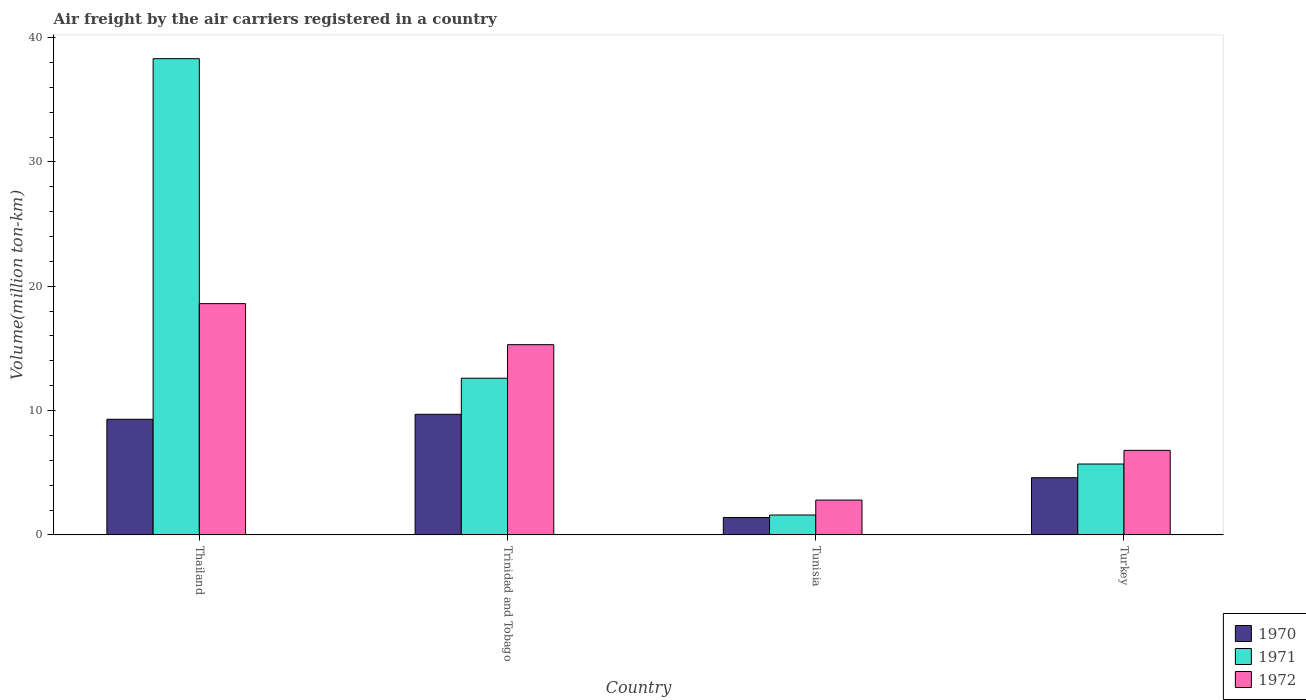Are the number of bars per tick equal to the number of legend labels?
Offer a terse response. Yes. How many bars are there on the 2nd tick from the left?
Your answer should be very brief. 3. How many bars are there on the 1st tick from the right?
Provide a short and direct response. 3. In how many cases, is the number of bars for a given country not equal to the number of legend labels?
Your answer should be very brief. 0. What is the volume of the air carriers in 1970 in Trinidad and Tobago?
Ensure brevity in your answer.  9.7. Across all countries, what is the maximum volume of the air carriers in 1970?
Make the answer very short. 9.7. Across all countries, what is the minimum volume of the air carriers in 1971?
Provide a succinct answer. 1.6. In which country was the volume of the air carriers in 1971 maximum?
Your answer should be very brief. Thailand. In which country was the volume of the air carriers in 1972 minimum?
Give a very brief answer. Tunisia. What is the total volume of the air carriers in 1971 in the graph?
Provide a short and direct response. 58.2. What is the difference between the volume of the air carriers in 1971 in Thailand and that in Trinidad and Tobago?
Your answer should be very brief. 25.7. What is the difference between the volume of the air carriers in 1972 in Tunisia and the volume of the air carriers in 1970 in Trinidad and Tobago?
Give a very brief answer. -6.9. What is the average volume of the air carriers in 1972 per country?
Offer a very short reply. 10.88. What is the difference between the volume of the air carriers of/in 1971 and volume of the air carriers of/in 1972 in Tunisia?
Keep it short and to the point. -1.2. What is the ratio of the volume of the air carriers in 1971 in Tunisia to that in Turkey?
Offer a very short reply. 0.28. Is the difference between the volume of the air carriers in 1971 in Trinidad and Tobago and Turkey greater than the difference between the volume of the air carriers in 1972 in Trinidad and Tobago and Turkey?
Your response must be concise. No. What is the difference between the highest and the second highest volume of the air carriers in 1971?
Keep it short and to the point. 6.9. What is the difference between the highest and the lowest volume of the air carriers in 1972?
Give a very brief answer. 15.8. In how many countries, is the volume of the air carriers in 1972 greater than the average volume of the air carriers in 1972 taken over all countries?
Ensure brevity in your answer.  2. Are all the bars in the graph horizontal?
Ensure brevity in your answer.  No. What is the difference between two consecutive major ticks on the Y-axis?
Offer a terse response. 10. Does the graph contain any zero values?
Your response must be concise. No. Does the graph contain grids?
Ensure brevity in your answer.  No. Where does the legend appear in the graph?
Your answer should be compact. Bottom right. How many legend labels are there?
Provide a succinct answer. 3. How are the legend labels stacked?
Provide a succinct answer. Vertical. What is the title of the graph?
Offer a very short reply. Air freight by the air carriers registered in a country. Does "1965" appear as one of the legend labels in the graph?
Your response must be concise. No. What is the label or title of the Y-axis?
Ensure brevity in your answer.  Volume(million ton-km). What is the Volume(million ton-km) in 1970 in Thailand?
Give a very brief answer. 9.3. What is the Volume(million ton-km) in 1971 in Thailand?
Offer a very short reply. 38.3. What is the Volume(million ton-km) in 1972 in Thailand?
Keep it short and to the point. 18.6. What is the Volume(million ton-km) of 1970 in Trinidad and Tobago?
Provide a short and direct response. 9.7. What is the Volume(million ton-km) in 1971 in Trinidad and Tobago?
Ensure brevity in your answer.  12.6. What is the Volume(million ton-km) in 1972 in Trinidad and Tobago?
Offer a very short reply. 15.3. What is the Volume(million ton-km) of 1970 in Tunisia?
Your answer should be compact. 1.4. What is the Volume(million ton-km) in 1971 in Tunisia?
Offer a very short reply. 1.6. What is the Volume(million ton-km) of 1972 in Tunisia?
Make the answer very short. 2.8. What is the Volume(million ton-km) of 1970 in Turkey?
Give a very brief answer. 4.6. What is the Volume(million ton-km) of 1971 in Turkey?
Your response must be concise. 5.7. What is the Volume(million ton-km) in 1972 in Turkey?
Your answer should be very brief. 6.8. Across all countries, what is the maximum Volume(million ton-km) in 1970?
Your response must be concise. 9.7. Across all countries, what is the maximum Volume(million ton-km) in 1971?
Provide a short and direct response. 38.3. Across all countries, what is the maximum Volume(million ton-km) in 1972?
Keep it short and to the point. 18.6. Across all countries, what is the minimum Volume(million ton-km) in 1970?
Your response must be concise. 1.4. Across all countries, what is the minimum Volume(million ton-km) in 1971?
Offer a very short reply. 1.6. Across all countries, what is the minimum Volume(million ton-km) in 1972?
Ensure brevity in your answer.  2.8. What is the total Volume(million ton-km) of 1971 in the graph?
Give a very brief answer. 58.2. What is the total Volume(million ton-km) in 1972 in the graph?
Offer a very short reply. 43.5. What is the difference between the Volume(million ton-km) in 1971 in Thailand and that in Trinidad and Tobago?
Provide a short and direct response. 25.7. What is the difference between the Volume(million ton-km) of 1972 in Thailand and that in Trinidad and Tobago?
Make the answer very short. 3.3. What is the difference between the Volume(million ton-km) of 1970 in Thailand and that in Tunisia?
Ensure brevity in your answer.  7.9. What is the difference between the Volume(million ton-km) in 1971 in Thailand and that in Tunisia?
Your answer should be very brief. 36.7. What is the difference between the Volume(million ton-km) in 1972 in Thailand and that in Tunisia?
Offer a very short reply. 15.8. What is the difference between the Volume(million ton-km) of 1971 in Thailand and that in Turkey?
Offer a very short reply. 32.6. What is the difference between the Volume(million ton-km) of 1970 in Trinidad and Tobago and that in Tunisia?
Your response must be concise. 8.3. What is the difference between the Volume(million ton-km) of 1971 in Trinidad and Tobago and that in Tunisia?
Give a very brief answer. 11. What is the difference between the Volume(million ton-km) in 1972 in Trinidad and Tobago and that in Tunisia?
Provide a short and direct response. 12.5. What is the difference between the Volume(million ton-km) of 1970 in Trinidad and Tobago and that in Turkey?
Make the answer very short. 5.1. What is the difference between the Volume(million ton-km) in 1971 in Trinidad and Tobago and that in Turkey?
Offer a terse response. 6.9. What is the difference between the Volume(million ton-km) in 1972 in Trinidad and Tobago and that in Turkey?
Keep it short and to the point. 8.5. What is the difference between the Volume(million ton-km) of 1971 in Tunisia and that in Turkey?
Give a very brief answer. -4.1. What is the difference between the Volume(million ton-km) in 1972 in Tunisia and that in Turkey?
Provide a short and direct response. -4. What is the difference between the Volume(million ton-km) of 1970 in Thailand and the Volume(million ton-km) of 1971 in Trinidad and Tobago?
Make the answer very short. -3.3. What is the difference between the Volume(million ton-km) in 1970 in Thailand and the Volume(million ton-km) in 1972 in Trinidad and Tobago?
Offer a terse response. -6. What is the difference between the Volume(million ton-km) in 1971 in Thailand and the Volume(million ton-km) in 1972 in Trinidad and Tobago?
Offer a terse response. 23. What is the difference between the Volume(million ton-km) of 1970 in Thailand and the Volume(million ton-km) of 1972 in Tunisia?
Keep it short and to the point. 6.5. What is the difference between the Volume(million ton-km) in 1971 in Thailand and the Volume(million ton-km) in 1972 in Tunisia?
Provide a succinct answer. 35.5. What is the difference between the Volume(million ton-km) in 1971 in Thailand and the Volume(million ton-km) in 1972 in Turkey?
Make the answer very short. 31.5. What is the difference between the Volume(million ton-km) of 1970 in Trinidad and Tobago and the Volume(million ton-km) of 1971 in Tunisia?
Provide a short and direct response. 8.1. What is the difference between the Volume(million ton-km) in 1971 in Trinidad and Tobago and the Volume(million ton-km) in 1972 in Tunisia?
Provide a short and direct response. 9.8. What is the difference between the Volume(million ton-km) of 1971 in Tunisia and the Volume(million ton-km) of 1972 in Turkey?
Offer a very short reply. -5.2. What is the average Volume(million ton-km) of 1970 per country?
Give a very brief answer. 6.25. What is the average Volume(million ton-km) of 1971 per country?
Ensure brevity in your answer.  14.55. What is the average Volume(million ton-km) of 1972 per country?
Provide a short and direct response. 10.88. What is the difference between the Volume(million ton-km) in 1971 and Volume(million ton-km) in 1972 in Thailand?
Offer a terse response. 19.7. What is the difference between the Volume(million ton-km) in 1970 and Volume(million ton-km) in 1971 in Trinidad and Tobago?
Offer a terse response. -2.9. What is the difference between the Volume(million ton-km) in 1971 and Volume(million ton-km) in 1972 in Trinidad and Tobago?
Offer a very short reply. -2.7. What is the difference between the Volume(million ton-km) in 1970 and Volume(million ton-km) in 1971 in Tunisia?
Provide a short and direct response. -0.2. What is the difference between the Volume(million ton-km) in 1971 and Volume(million ton-km) in 1972 in Tunisia?
Make the answer very short. -1.2. What is the difference between the Volume(million ton-km) in 1970 and Volume(million ton-km) in 1972 in Turkey?
Give a very brief answer. -2.2. What is the difference between the Volume(million ton-km) of 1971 and Volume(million ton-km) of 1972 in Turkey?
Provide a succinct answer. -1.1. What is the ratio of the Volume(million ton-km) of 1970 in Thailand to that in Trinidad and Tobago?
Ensure brevity in your answer.  0.96. What is the ratio of the Volume(million ton-km) in 1971 in Thailand to that in Trinidad and Tobago?
Ensure brevity in your answer.  3.04. What is the ratio of the Volume(million ton-km) in 1972 in Thailand to that in Trinidad and Tobago?
Keep it short and to the point. 1.22. What is the ratio of the Volume(million ton-km) in 1970 in Thailand to that in Tunisia?
Your answer should be compact. 6.64. What is the ratio of the Volume(million ton-km) in 1971 in Thailand to that in Tunisia?
Give a very brief answer. 23.94. What is the ratio of the Volume(million ton-km) in 1972 in Thailand to that in Tunisia?
Your answer should be compact. 6.64. What is the ratio of the Volume(million ton-km) in 1970 in Thailand to that in Turkey?
Give a very brief answer. 2.02. What is the ratio of the Volume(million ton-km) in 1971 in Thailand to that in Turkey?
Make the answer very short. 6.72. What is the ratio of the Volume(million ton-km) in 1972 in Thailand to that in Turkey?
Give a very brief answer. 2.74. What is the ratio of the Volume(million ton-km) of 1970 in Trinidad and Tobago to that in Tunisia?
Provide a succinct answer. 6.93. What is the ratio of the Volume(million ton-km) of 1971 in Trinidad and Tobago to that in Tunisia?
Your response must be concise. 7.88. What is the ratio of the Volume(million ton-km) in 1972 in Trinidad and Tobago to that in Tunisia?
Your answer should be very brief. 5.46. What is the ratio of the Volume(million ton-km) of 1970 in Trinidad and Tobago to that in Turkey?
Keep it short and to the point. 2.11. What is the ratio of the Volume(million ton-km) of 1971 in Trinidad and Tobago to that in Turkey?
Give a very brief answer. 2.21. What is the ratio of the Volume(million ton-km) of 1972 in Trinidad and Tobago to that in Turkey?
Offer a terse response. 2.25. What is the ratio of the Volume(million ton-km) in 1970 in Tunisia to that in Turkey?
Give a very brief answer. 0.3. What is the ratio of the Volume(million ton-km) of 1971 in Tunisia to that in Turkey?
Provide a succinct answer. 0.28. What is the ratio of the Volume(million ton-km) in 1972 in Tunisia to that in Turkey?
Make the answer very short. 0.41. What is the difference between the highest and the second highest Volume(million ton-km) of 1971?
Provide a short and direct response. 25.7. What is the difference between the highest and the second highest Volume(million ton-km) of 1972?
Your response must be concise. 3.3. What is the difference between the highest and the lowest Volume(million ton-km) of 1970?
Offer a terse response. 8.3. What is the difference between the highest and the lowest Volume(million ton-km) in 1971?
Make the answer very short. 36.7. 